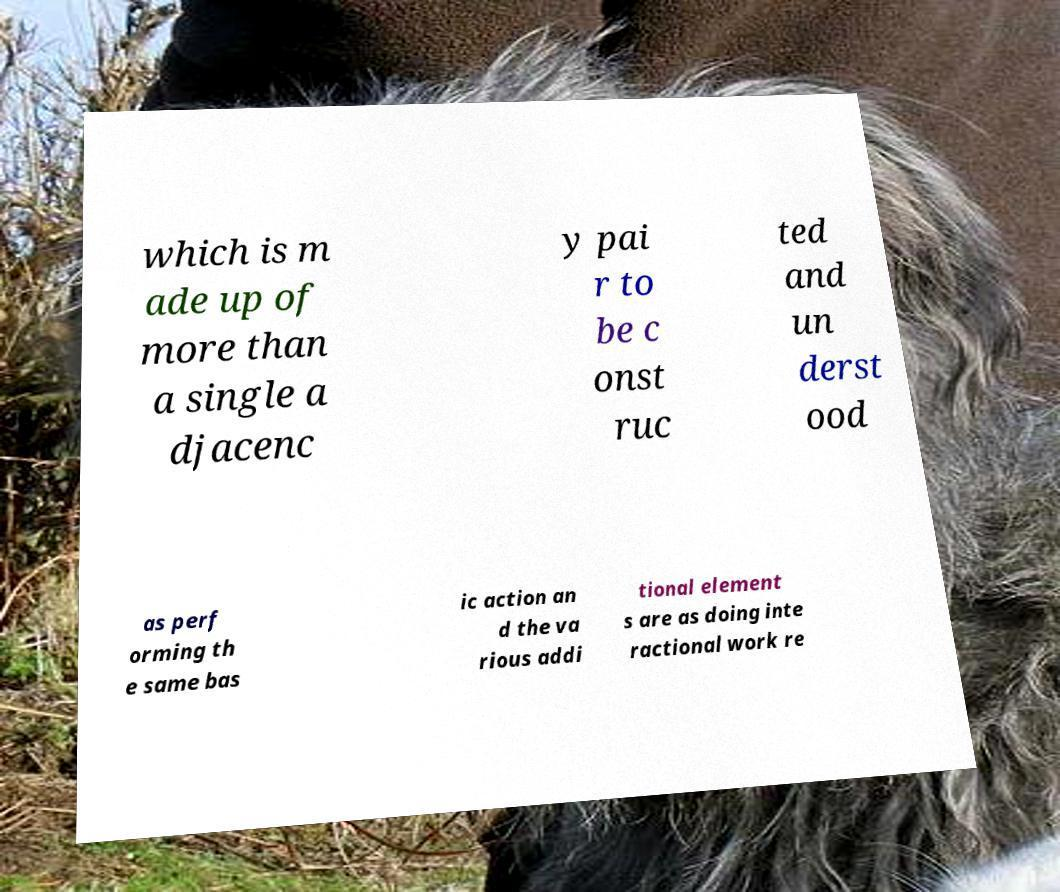There's text embedded in this image that I need extracted. Can you transcribe it verbatim? which is m ade up of more than a single a djacenc y pai r to be c onst ruc ted and un derst ood as perf orming th e same bas ic action an d the va rious addi tional element s are as doing inte ractional work re 